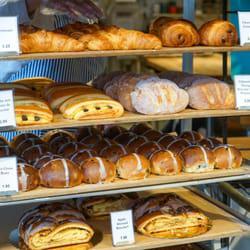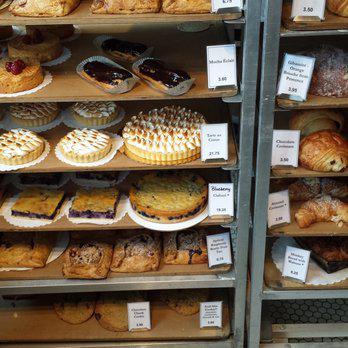The first image is the image on the left, the second image is the image on the right. For the images shown, is this caption "In at least one image there is a single brown front door under blue signage." true? Answer yes or no. No. The first image is the image on the left, the second image is the image on the right. Evaluate the accuracy of this statement regarding the images: "There is a metal rack with various breads and pastries on it, there are tags in the image on the shelves labeling the products". Is it true? Answer yes or no. Yes. 